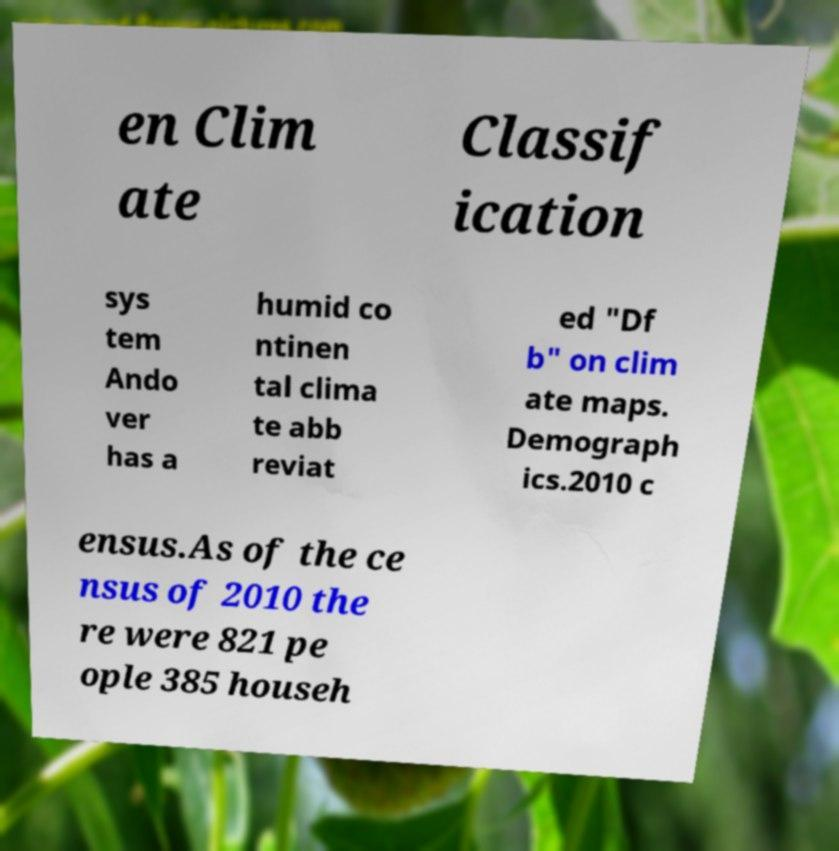Please identify and transcribe the text found in this image. en Clim ate Classif ication sys tem Ando ver has a humid co ntinen tal clima te abb reviat ed "Df b" on clim ate maps. Demograph ics.2010 c ensus.As of the ce nsus of 2010 the re were 821 pe ople 385 househ 